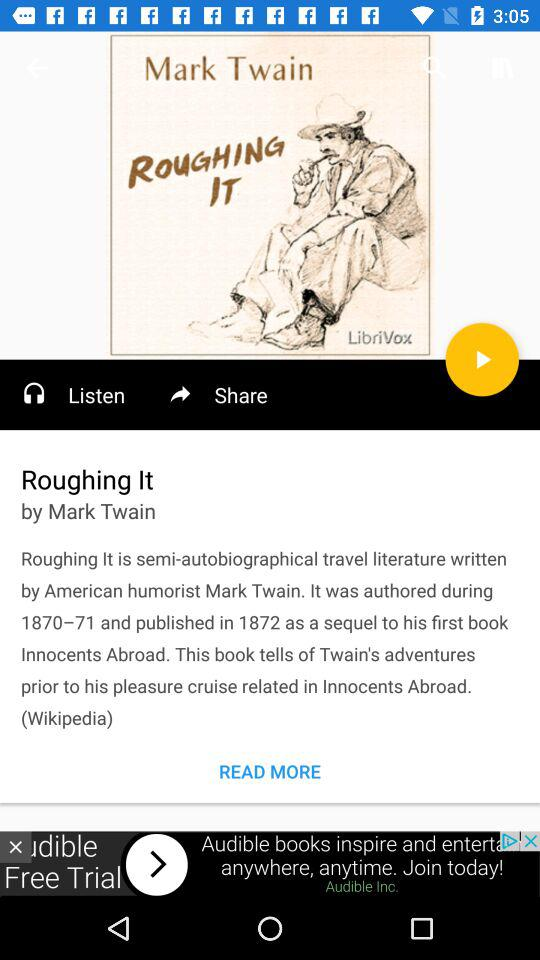What is the publication year of Roughing It? The publication year of Roughing It is 1872. 